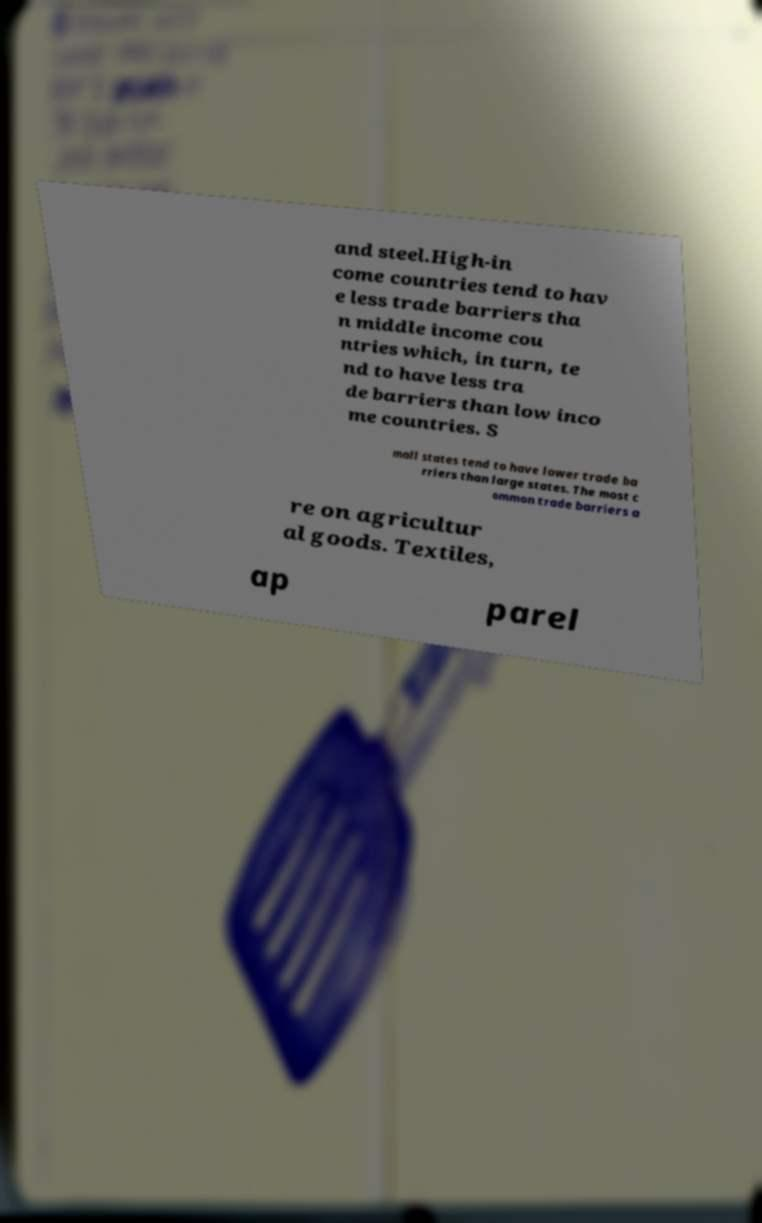For documentation purposes, I need the text within this image transcribed. Could you provide that? and steel.High-in come countries tend to hav e less trade barriers tha n middle income cou ntries which, in turn, te nd to have less tra de barriers than low inco me countries. S mall states tend to have lower trade ba rriers than large states. The most c ommon trade barriers a re on agricultur al goods. Textiles, ap parel 